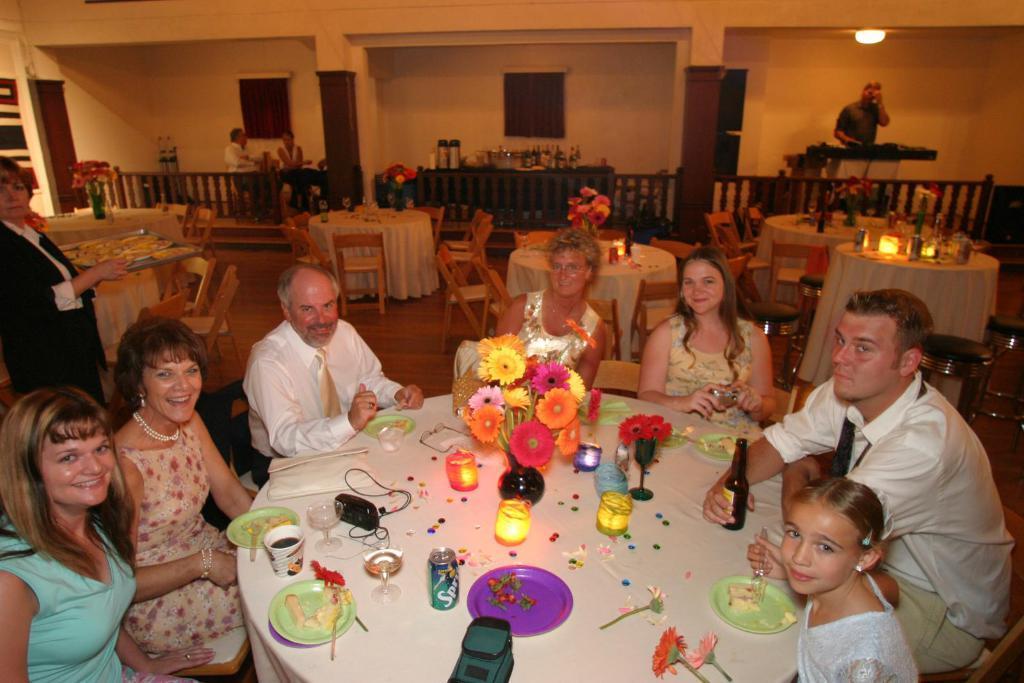Please provide a concise description of this image. There are so many people sitting in a chair in front of a table where there is food served in table and some candles with the flower ways and behind them there are so many people and so many tables and chairs. 